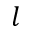Convert formula to latex. <formula><loc_0><loc_0><loc_500><loc_500>l</formula> 